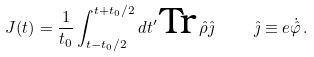<formula> <loc_0><loc_0><loc_500><loc_500>J ( t ) = \frac { 1 } { t _ { 0 } } \int _ { t - t _ { 0 } / 2 } ^ { t + t _ { 0 } / 2 } d t ^ { \prime } \, \text {Tr} \, { \hat { \rho } } { \hat { \jmath } } \, \quad \hat { \jmath } \equiv e { \dot { \hat { \varphi } } } \, .</formula> 